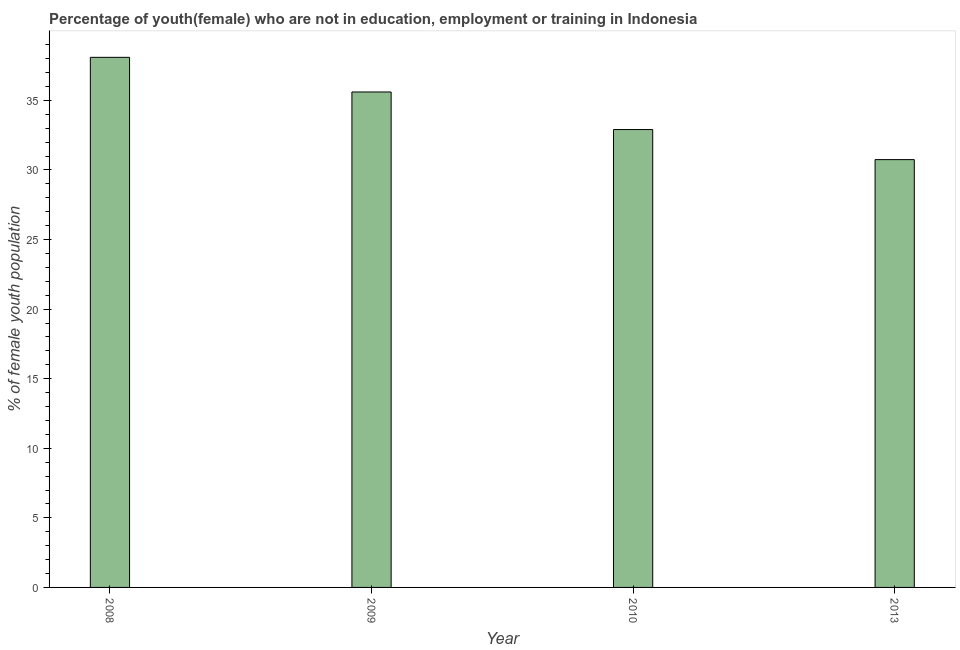Does the graph contain grids?
Keep it short and to the point. No. What is the title of the graph?
Keep it short and to the point. Percentage of youth(female) who are not in education, employment or training in Indonesia. What is the label or title of the Y-axis?
Provide a succinct answer. % of female youth population. What is the unemployed female youth population in 2009?
Give a very brief answer. 35.6. Across all years, what is the maximum unemployed female youth population?
Your answer should be compact. 38.09. Across all years, what is the minimum unemployed female youth population?
Your answer should be compact. 30.74. What is the sum of the unemployed female youth population?
Make the answer very short. 137.33. What is the difference between the unemployed female youth population in 2009 and 2010?
Provide a short and direct response. 2.7. What is the average unemployed female youth population per year?
Offer a terse response. 34.33. What is the median unemployed female youth population?
Offer a very short reply. 34.25. What is the ratio of the unemployed female youth population in 2009 to that in 2010?
Make the answer very short. 1.08. Is the unemployed female youth population in 2009 less than that in 2013?
Provide a succinct answer. No. Is the difference between the unemployed female youth population in 2009 and 2013 greater than the difference between any two years?
Offer a very short reply. No. What is the difference between the highest and the second highest unemployed female youth population?
Provide a short and direct response. 2.49. Is the sum of the unemployed female youth population in 2009 and 2010 greater than the maximum unemployed female youth population across all years?
Offer a terse response. Yes. What is the difference between the highest and the lowest unemployed female youth population?
Offer a terse response. 7.35. In how many years, is the unemployed female youth population greater than the average unemployed female youth population taken over all years?
Keep it short and to the point. 2. Are all the bars in the graph horizontal?
Your answer should be very brief. No. What is the difference between two consecutive major ticks on the Y-axis?
Your response must be concise. 5. What is the % of female youth population in 2008?
Give a very brief answer. 38.09. What is the % of female youth population of 2009?
Ensure brevity in your answer.  35.6. What is the % of female youth population of 2010?
Make the answer very short. 32.9. What is the % of female youth population of 2013?
Ensure brevity in your answer.  30.74. What is the difference between the % of female youth population in 2008 and 2009?
Keep it short and to the point. 2.49. What is the difference between the % of female youth population in 2008 and 2010?
Give a very brief answer. 5.19. What is the difference between the % of female youth population in 2008 and 2013?
Your answer should be very brief. 7.35. What is the difference between the % of female youth population in 2009 and 2010?
Provide a succinct answer. 2.7. What is the difference between the % of female youth population in 2009 and 2013?
Offer a terse response. 4.86. What is the difference between the % of female youth population in 2010 and 2013?
Your response must be concise. 2.16. What is the ratio of the % of female youth population in 2008 to that in 2009?
Offer a very short reply. 1.07. What is the ratio of the % of female youth population in 2008 to that in 2010?
Your answer should be very brief. 1.16. What is the ratio of the % of female youth population in 2008 to that in 2013?
Your response must be concise. 1.24. What is the ratio of the % of female youth population in 2009 to that in 2010?
Offer a very short reply. 1.08. What is the ratio of the % of female youth population in 2009 to that in 2013?
Your response must be concise. 1.16. What is the ratio of the % of female youth population in 2010 to that in 2013?
Your answer should be very brief. 1.07. 